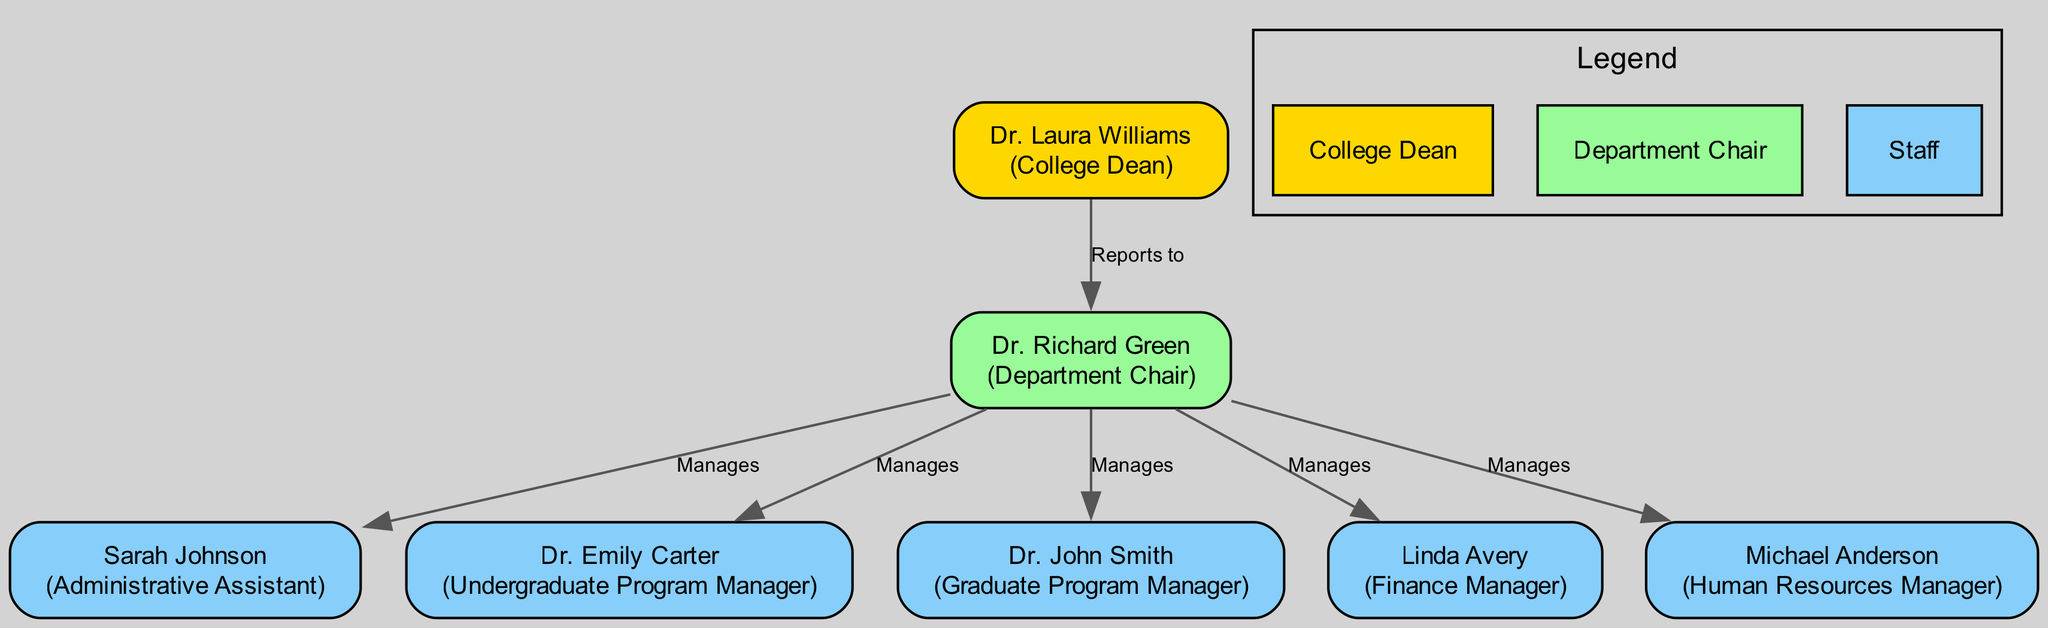What's the role of the top node? The top node, which is the College Dean, has the role of "College Dean". This is specified directly in the diagram where the node identifies their name and role.
Answer: College Dean Who does Dr. Richard Green report to? The diagram indicates that Dr. Richard Green, the Department Chair, reports to the College Dean, Dr. Laura Williams, as shown by the connection labeled "Reports to".
Answer: College Dean How many direct reports does Dr. Richard Green have? Counting the nodes directly connected to Dr. Richard Green, he has four direct reports: one Administrative Assistant, two Program Managers, one Finance Manager, and one HR Manager.
Answer: 4 What is the responsibility of the Finance Manager? The diagram outlines that the Finance Manager, Linda Avery, has the responsibility of "Budget Planning". This is one of the specific responsibilities listed under her role.
Answer: Budget Planning Which role manages Graduate Admissions? In the diagram, Dr. John Smith is identified as the Graduate Program Manager, and one of his responsibilities is specifically listed as "Graduate Admissions".
Answer: Dr. John Smith What is the relationship between the College Dean and the Department Chair? The diagram shows a directed edge from the College Dean to the Department Chair, indicating that the College Dean oversees or leads the Department Chair by the label "Reports to".
Answer: Oversees What is the color indicating the College Dean in the diagram? The College Dean is represented in gold in the diagram, as the color is specified for the node representing the College Dean.
Answer: Gold List one responsibility of the Human Resources Manager. The diagram indicates that the Human Resources Manager, Michael Anderson, has several responsibilities, one of which is "Staff Recruitment". This particular responsibility can be directly read from the node related to him.
Answer: Staff Recruitment How many Program Managers report to Dr. Richard Green? In the diagram, there are two Program Managers, namely Dr. Emily Carter and Dr. John Smith, both directly reporting to Dr. Richard Green.
Answer: 2 